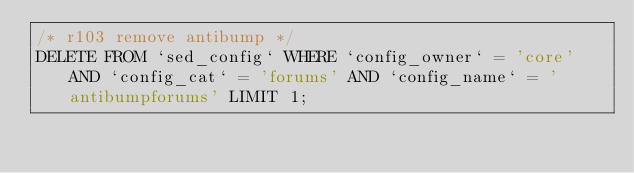<code> <loc_0><loc_0><loc_500><loc_500><_SQL_>/* r103 remove antibump */
DELETE FROM `sed_config` WHERE `config_owner` = 'core' AND `config_cat` = 'forums' AND `config_name` = 'antibumpforums' LIMIT 1;</code> 